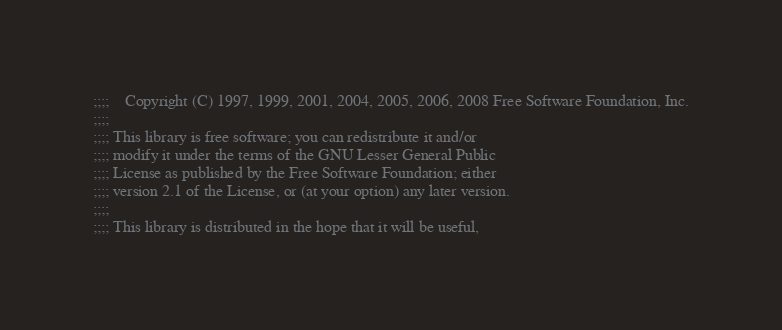<code> <loc_0><loc_0><loc_500><loc_500><_Scheme_>;;;; 	Copyright (C) 1997, 1999, 2001, 2004, 2005, 2006, 2008 Free Software Foundation, Inc.
;;;;
;;;; This library is free software; you can redistribute it and/or
;;;; modify it under the terms of the GNU Lesser General Public
;;;; License as published by the Free Software Foundation; either
;;;; version 2.1 of the License, or (at your option) any later version.
;;;; 
;;;; This library is distributed in the hope that it will be useful,</code> 